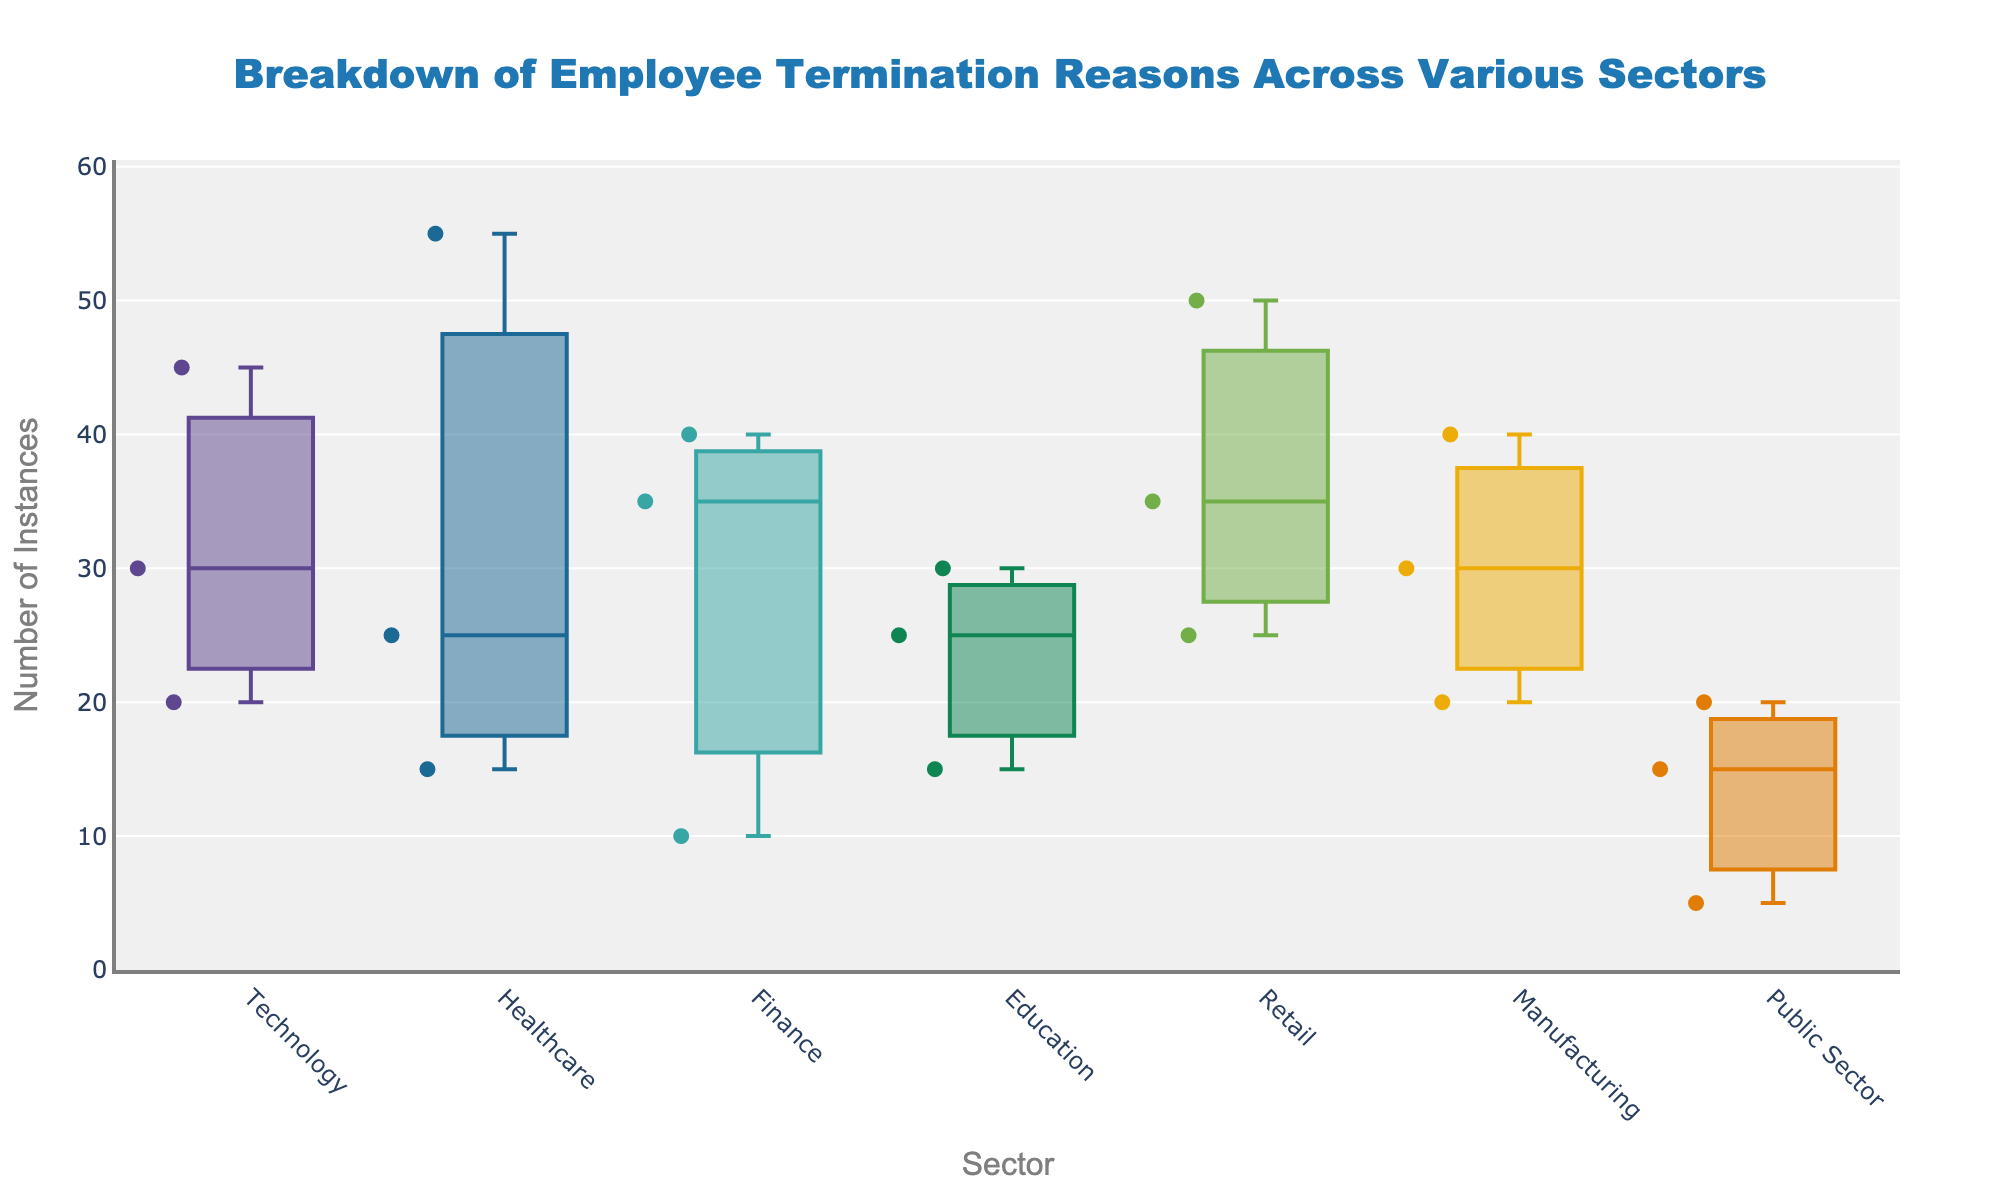What is the title of the figure? The figure's title is normally positioned at the top of the plot and is used to describe the content or purpose of the plot. Here, it's centered and formatted.
Answer: Breakdown of Employee Termination Reasons Across Various Sectors Which sector has the highest maximum value for the number of termination instances? By examining the box plots, the sector with the highest maximum value will have the highest upper whisker. The Retail sector has the highest whisker, indicating the highest maximum value.
Answer: Retail What is the median number of termination instances in the Technology sector? The median value is indicated by the line inside the box of the Technology sector's box plot. This line represents the midpoint of the data distribution for that sector.
Answer: 30 How do the number of termination instances in the Finance and Public Sector compare? The box plot will allow us to compare the central tendency (median) and the spread (range, IQR) of the number of termination instances between Finance and Public Sector. The Finance sector has higher termination instances than the Public Sector.
Answer: Finance has higher instances Which sector has the smallest range of termination instances? The range is the distance between the smallest and largest values. The sector with the shortest whiskers combined (indicating the smallest span between min and max) will have the smallest range. The Public Sector's plot is the most compact.
Answer: Public Sector In which sector is misconduct as a reason for termination the least frequent? Look at the scatter points within each box plot for the lowest values and compare them across sectors. The Public Sector and Finance have very few instances of misconduct, with the Public Sector being the least.
Answer: Public Sector What are the common termination reasons highlighted across all sectors? The analysis of scatter points within the box plots indicates the labeled termination reasons like Restructuring, Performance, and Misconduct that are common across the sectors. These are consistently represented data points.
Answer: Restructuring, Performance, Misconduct What is the interquartile range (IQR) of termination instances in the Healthcare sector? The IQR can be determined from the box plot by subtracting the first quartile (Q1) value from the third quartile (Q3) value. In the Healthcare sector, Q3 is around 55, and Q1 is around 15, leading to an IQR of (55-15).
Answer: 40 Which termination reason appears most frequently in the Manufacturing sector? Identify the marks representing different termination reasons and count how many instances there are for each within the Manufacturing sector’s box plot. Restructuring has a higher number of scatter points compared to other reasons.
Answer: Restructuring What is the average number of termination instances for all reasons in the Technology sector? Calculate the average by summing up all instances (45 for Restructuring, 30 for Performance, 20 for Misconduct) and dividing by the number of instances (3). The sum is 95, divided by 3 gives around 31.7.
Answer: 31.7 